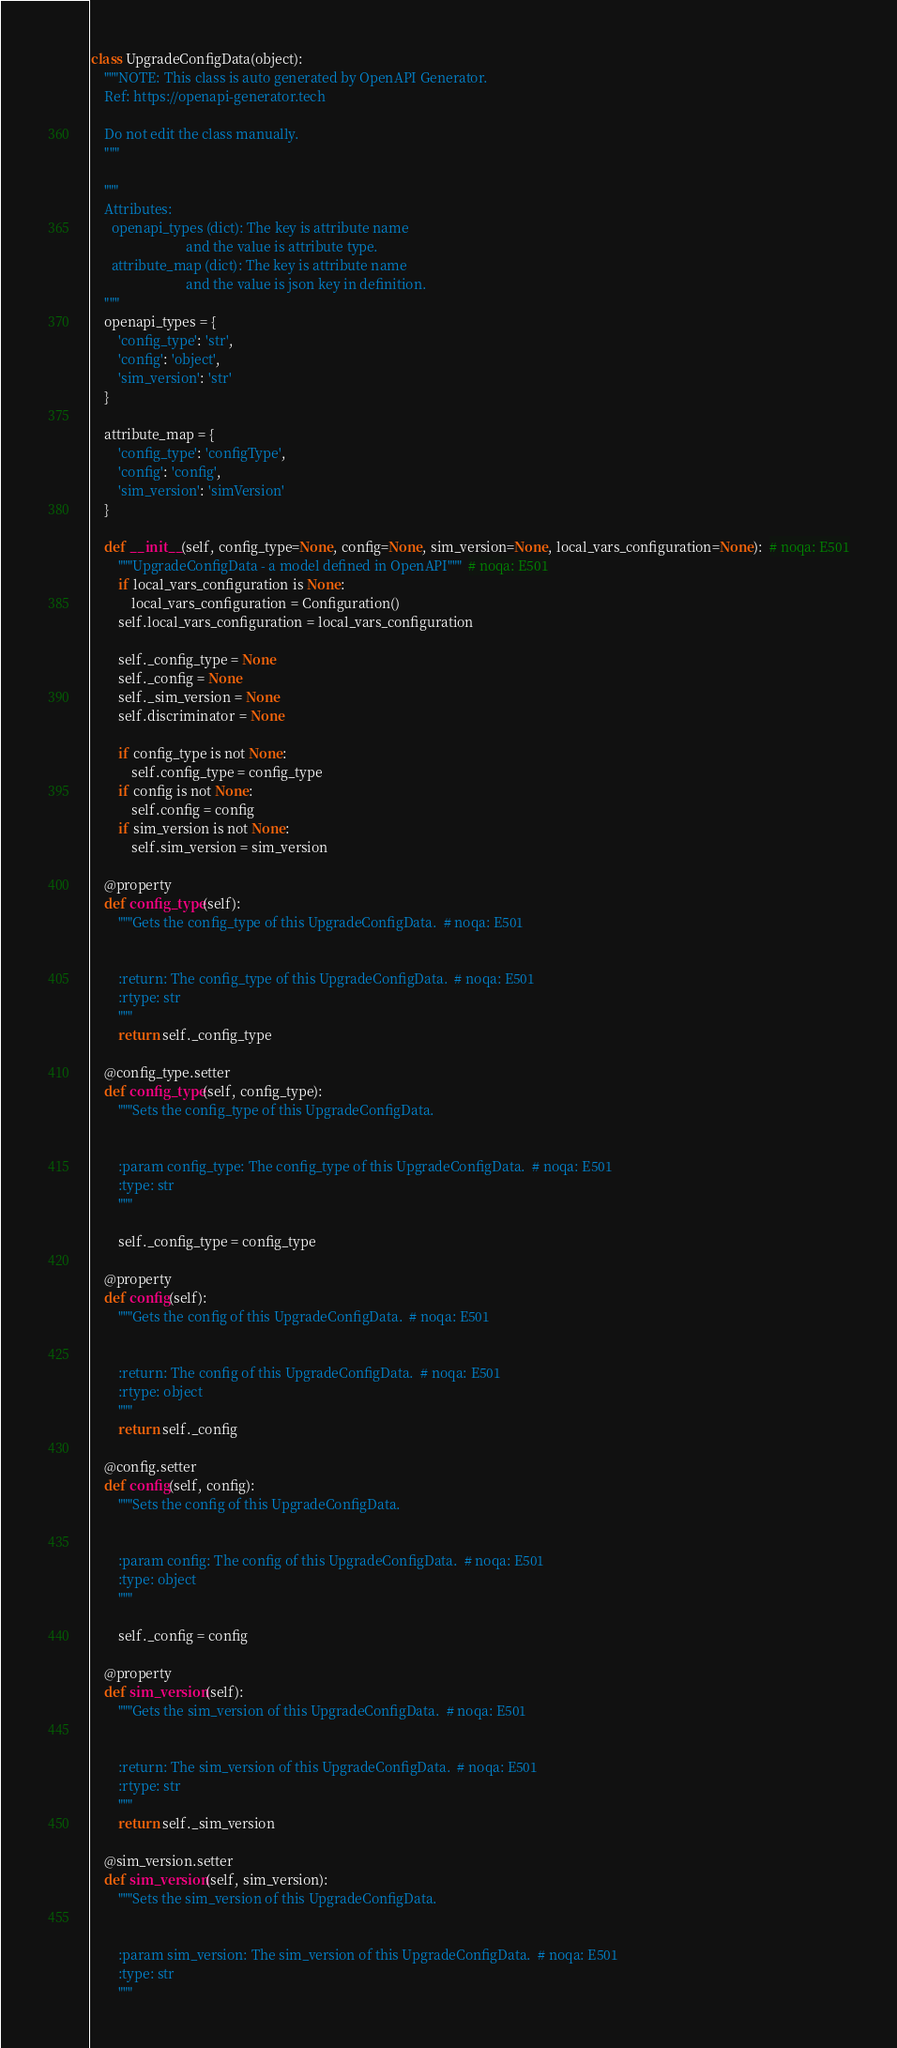Convert code to text. <code><loc_0><loc_0><loc_500><loc_500><_Python_>class UpgradeConfigData(object):
    """NOTE: This class is auto generated by OpenAPI Generator.
    Ref: https://openapi-generator.tech

    Do not edit the class manually.
    """

    """
    Attributes:
      openapi_types (dict): The key is attribute name
                            and the value is attribute type.
      attribute_map (dict): The key is attribute name
                            and the value is json key in definition.
    """
    openapi_types = {
        'config_type': 'str',
        'config': 'object',
        'sim_version': 'str'
    }

    attribute_map = {
        'config_type': 'configType',
        'config': 'config',
        'sim_version': 'simVersion'
    }

    def __init__(self, config_type=None, config=None, sim_version=None, local_vars_configuration=None):  # noqa: E501
        """UpgradeConfigData - a model defined in OpenAPI"""  # noqa: E501
        if local_vars_configuration is None:
            local_vars_configuration = Configuration()
        self.local_vars_configuration = local_vars_configuration

        self._config_type = None
        self._config = None
        self._sim_version = None
        self.discriminator = None

        if config_type is not None:
            self.config_type = config_type
        if config is not None:
            self.config = config
        if sim_version is not None:
            self.sim_version = sim_version

    @property
    def config_type(self):
        """Gets the config_type of this UpgradeConfigData.  # noqa: E501


        :return: The config_type of this UpgradeConfigData.  # noqa: E501
        :rtype: str
        """
        return self._config_type

    @config_type.setter
    def config_type(self, config_type):
        """Sets the config_type of this UpgradeConfigData.


        :param config_type: The config_type of this UpgradeConfigData.  # noqa: E501
        :type: str
        """

        self._config_type = config_type

    @property
    def config(self):
        """Gets the config of this UpgradeConfigData.  # noqa: E501


        :return: The config of this UpgradeConfigData.  # noqa: E501
        :rtype: object
        """
        return self._config

    @config.setter
    def config(self, config):
        """Sets the config of this UpgradeConfigData.


        :param config: The config of this UpgradeConfigData.  # noqa: E501
        :type: object
        """

        self._config = config

    @property
    def sim_version(self):
        """Gets the sim_version of this UpgradeConfigData.  # noqa: E501


        :return: The sim_version of this UpgradeConfigData.  # noqa: E501
        :rtype: str
        """
        return self._sim_version

    @sim_version.setter
    def sim_version(self, sim_version):
        """Sets the sim_version of this UpgradeConfigData.


        :param sim_version: The sim_version of this UpgradeConfigData.  # noqa: E501
        :type: str
        """
</code> 